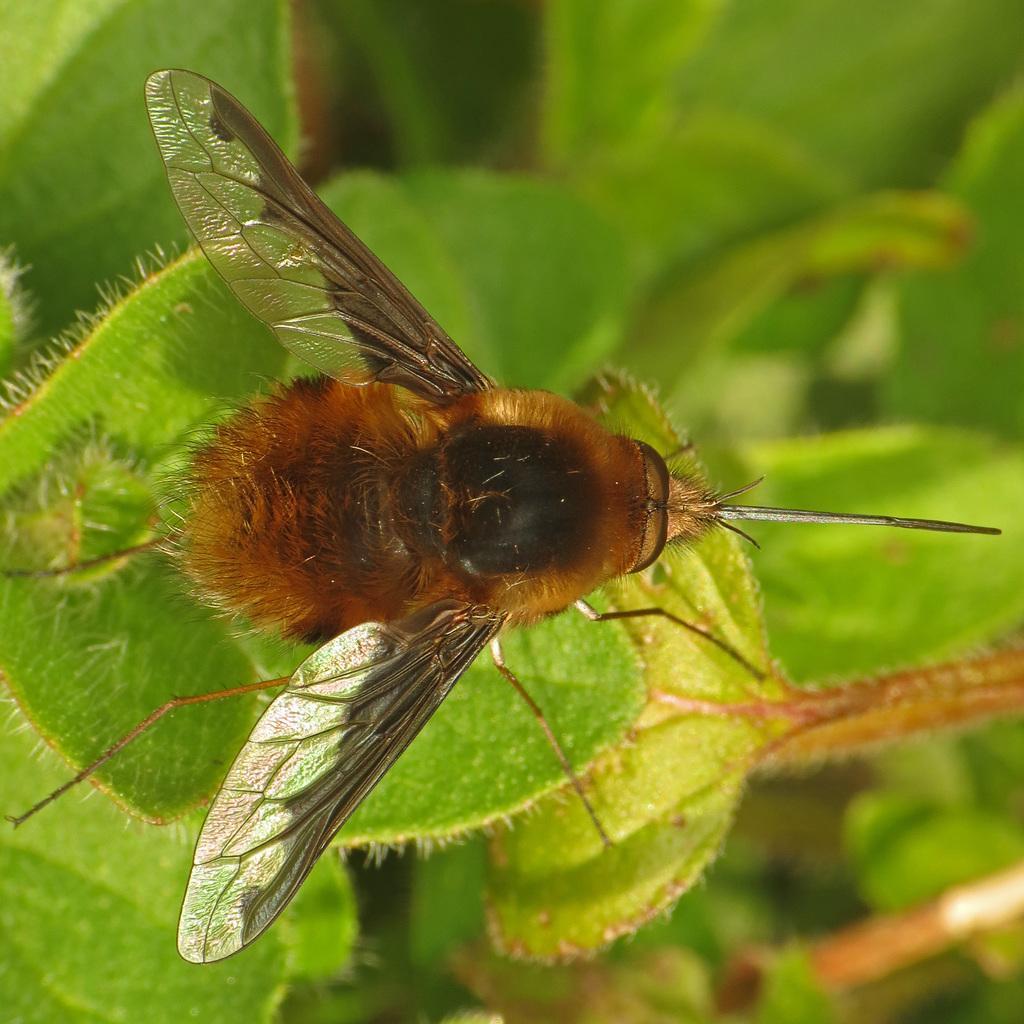How would you summarize this image in a sentence or two? Here in this image we can see the house fly sitting on the green leaves. 